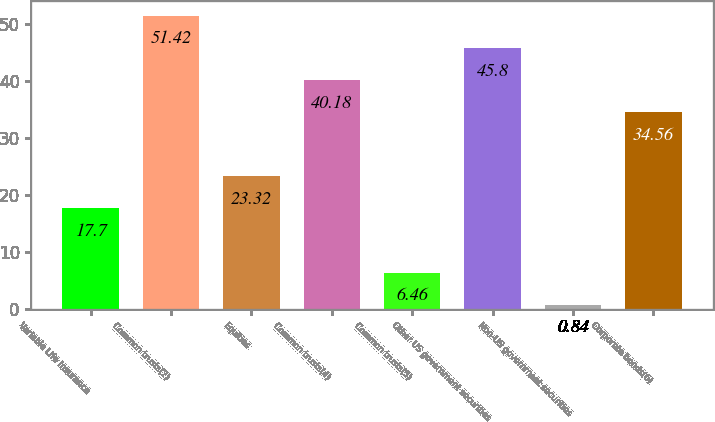Convert chart to OTSL. <chart><loc_0><loc_0><loc_500><loc_500><bar_chart><fcel>Variable Life Insurance<fcel>Common trusts(2)<fcel>Equities<fcel>Common trusts(4)<fcel>Common trusts(5)<fcel>Other US government securities<fcel>Non-US government securities<fcel>Corporate bonds(6)<nl><fcel>17.7<fcel>51.42<fcel>23.32<fcel>40.18<fcel>6.46<fcel>45.8<fcel>0.84<fcel>34.56<nl></chart> 